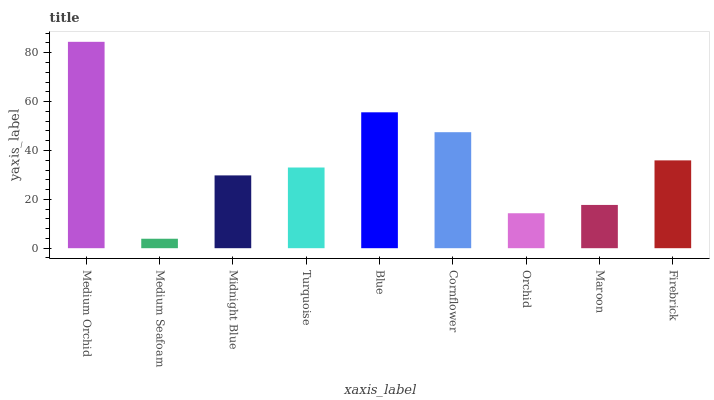Is Medium Seafoam the minimum?
Answer yes or no. Yes. Is Medium Orchid the maximum?
Answer yes or no. Yes. Is Midnight Blue the minimum?
Answer yes or no. No. Is Midnight Blue the maximum?
Answer yes or no. No. Is Midnight Blue greater than Medium Seafoam?
Answer yes or no. Yes. Is Medium Seafoam less than Midnight Blue?
Answer yes or no. Yes. Is Medium Seafoam greater than Midnight Blue?
Answer yes or no. No. Is Midnight Blue less than Medium Seafoam?
Answer yes or no. No. Is Turquoise the high median?
Answer yes or no. Yes. Is Turquoise the low median?
Answer yes or no. Yes. Is Medium Orchid the high median?
Answer yes or no. No. Is Medium Seafoam the low median?
Answer yes or no. No. 